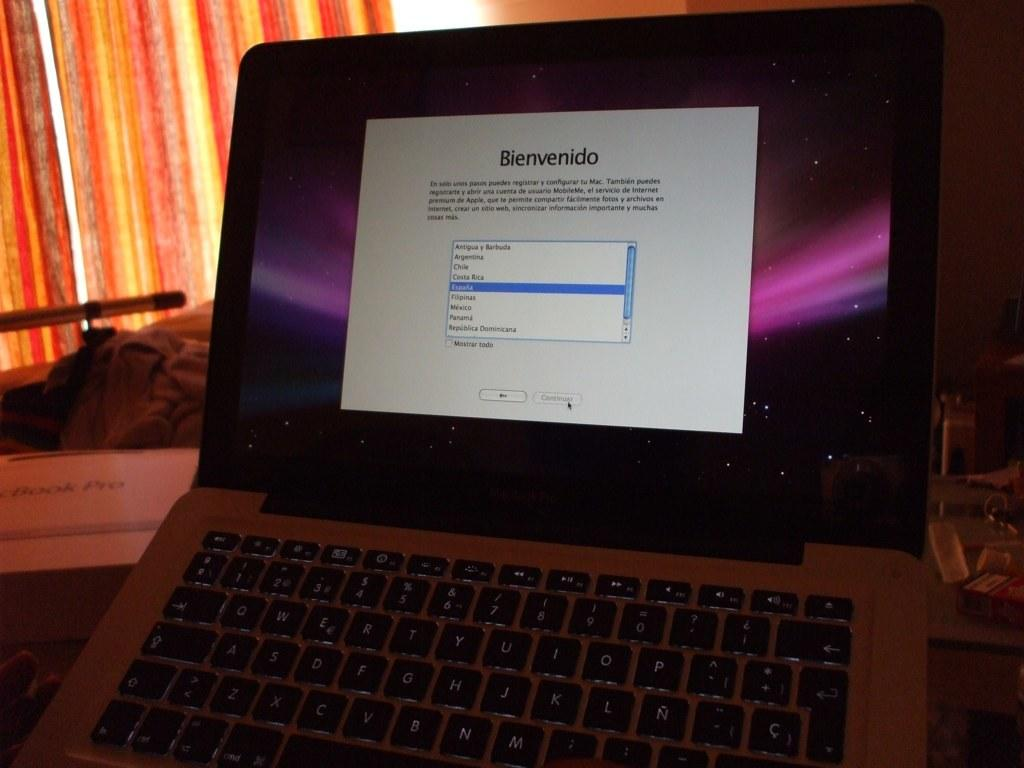<image>
Summarize the visual content of the image. A Macintosh laptop with the word Bienvenido on it. 